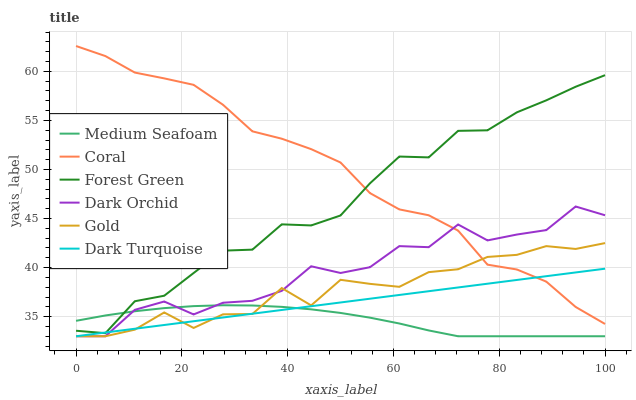Does Medium Seafoam have the minimum area under the curve?
Answer yes or no. Yes. Does Coral have the maximum area under the curve?
Answer yes or no. Yes. Does Dark Turquoise have the minimum area under the curve?
Answer yes or no. No. Does Dark Turquoise have the maximum area under the curve?
Answer yes or no. No. Is Dark Turquoise the smoothest?
Answer yes or no. Yes. Is Dark Orchid the roughest?
Answer yes or no. Yes. Is Coral the smoothest?
Answer yes or no. No. Is Coral the roughest?
Answer yes or no. No. Does Coral have the lowest value?
Answer yes or no. No. Does Coral have the highest value?
Answer yes or no. Yes. Does Dark Turquoise have the highest value?
Answer yes or no. No. Is Gold less than Forest Green?
Answer yes or no. Yes. Is Forest Green greater than Dark Orchid?
Answer yes or no. Yes. Does Gold intersect Forest Green?
Answer yes or no. No. 